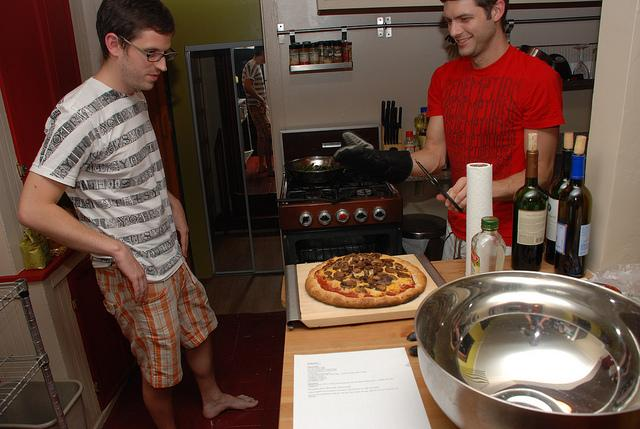How many bottles of wine are to the right in front to the man who is cutting the pizza? three 